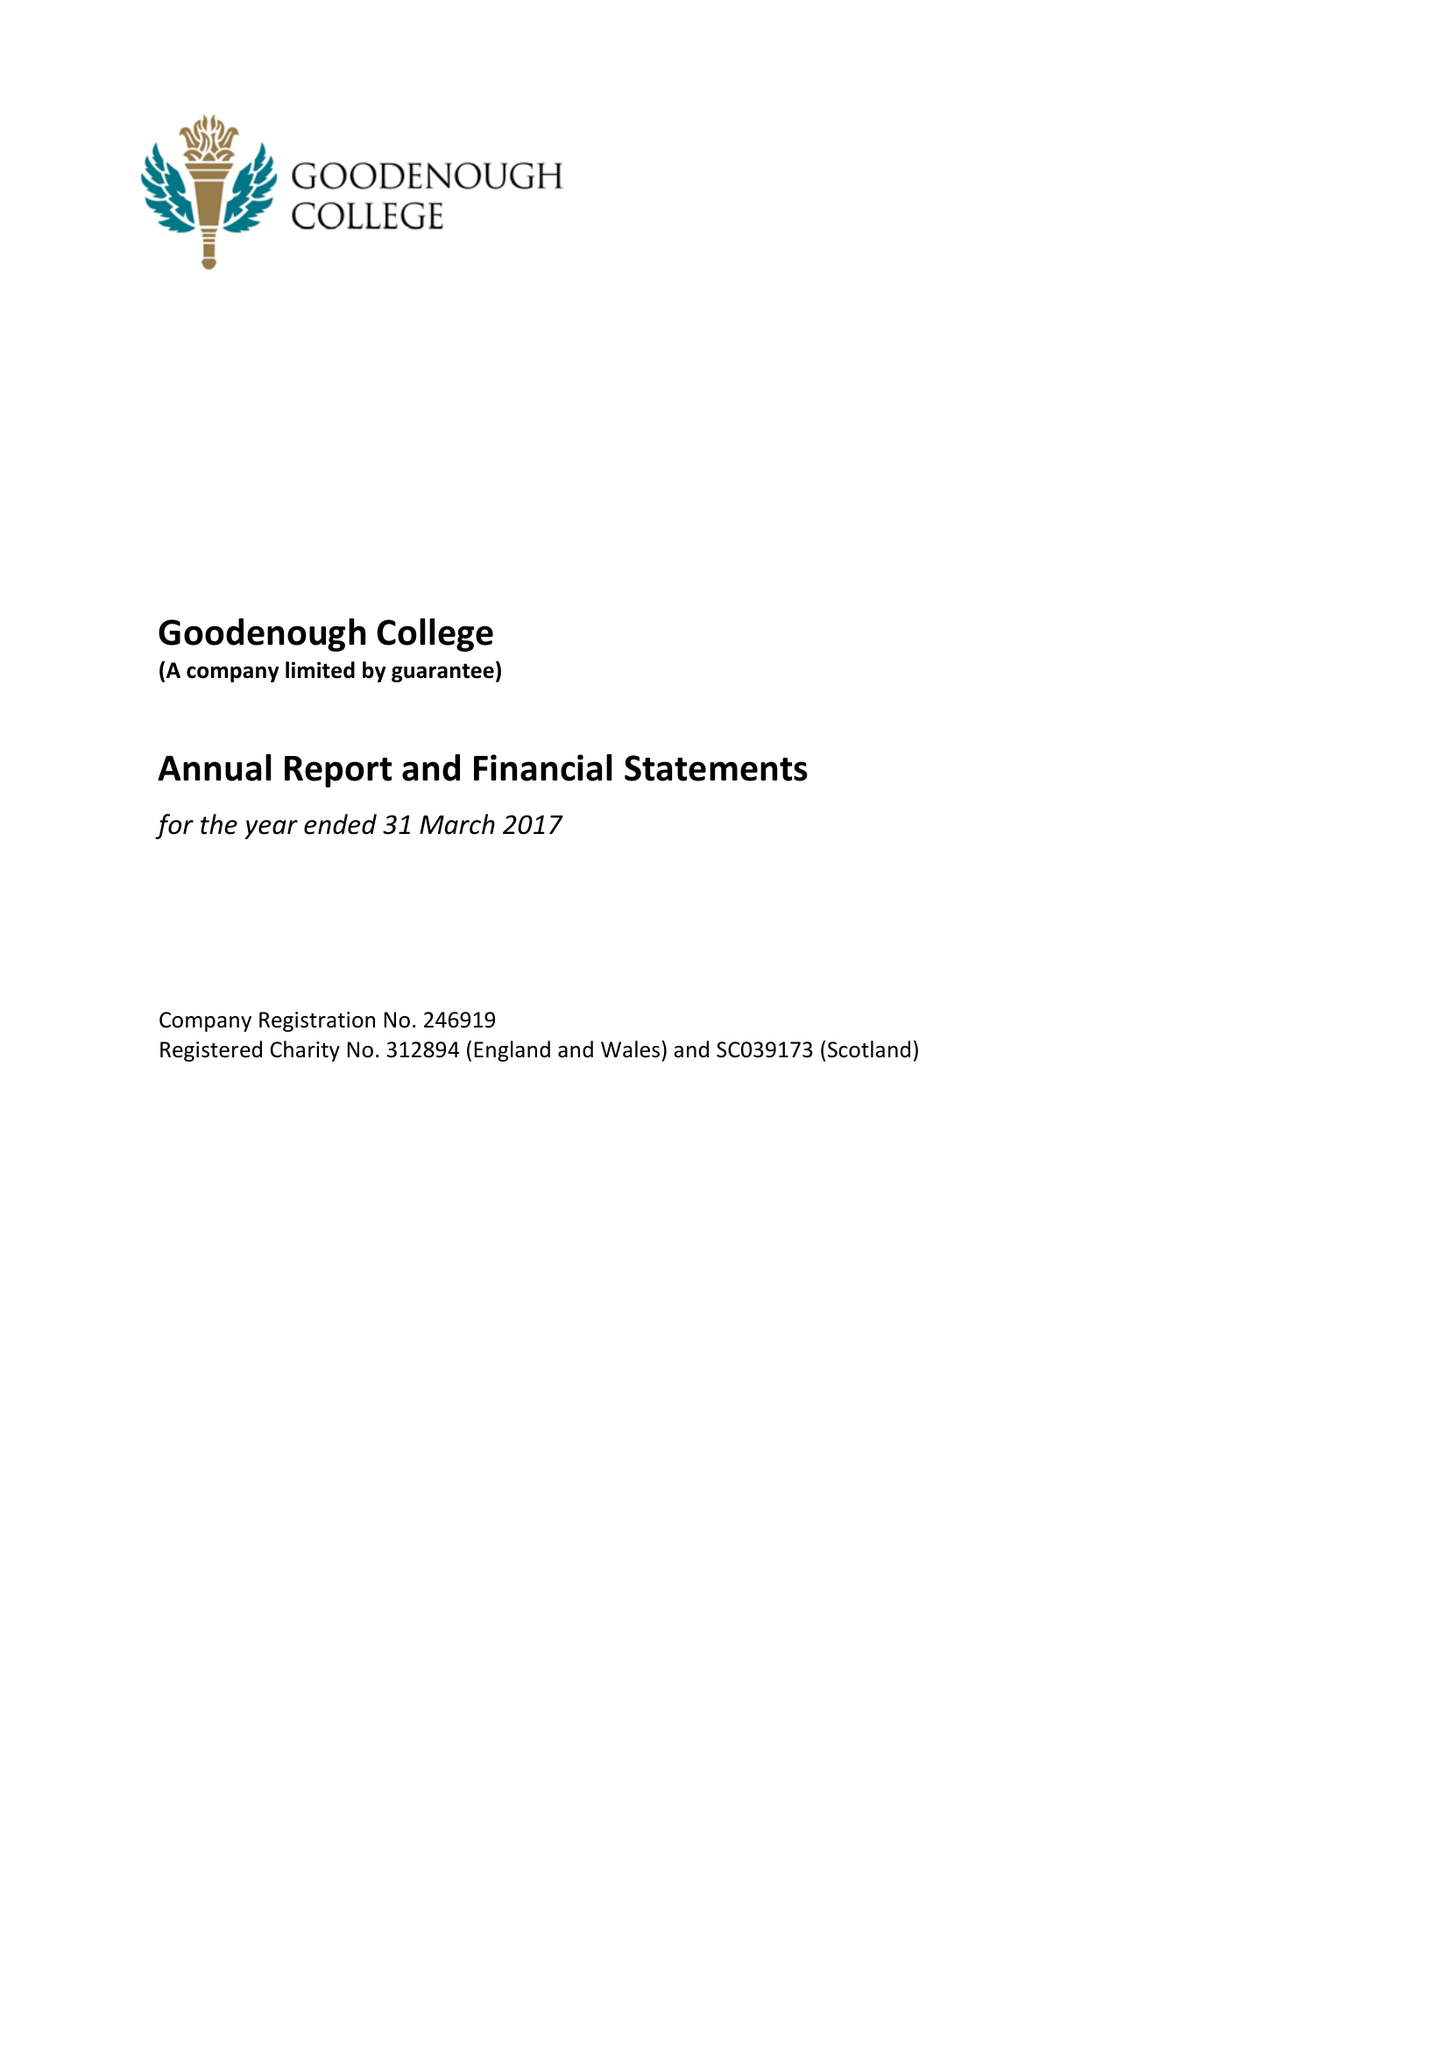What is the value for the address__postcode?
Answer the question using a single word or phrase. WC1N 2AB 